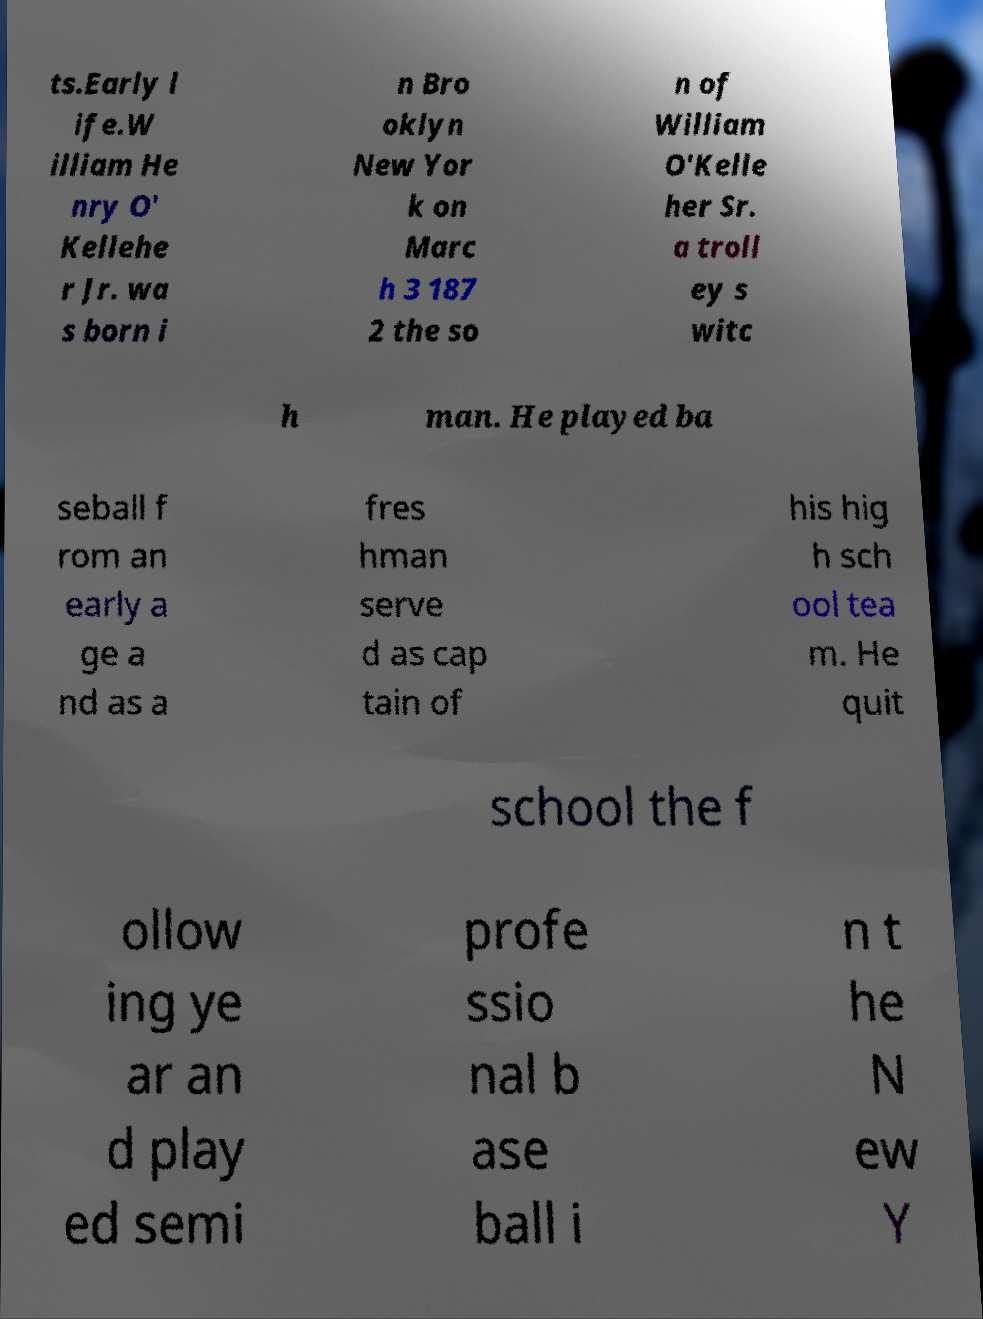What messages or text are displayed in this image? I need them in a readable, typed format. ts.Early l ife.W illiam He nry O' Kellehe r Jr. wa s born i n Bro oklyn New Yor k on Marc h 3 187 2 the so n of William O'Kelle her Sr. a troll ey s witc h man. He played ba seball f rom an early a ge a nd as a fres hman serve d as cap tain of his hig h sch ool tea m. He quit school the f ollow ing ye ar an d play ed semi profe ssio nal b ase ball i n t he N ew Y 